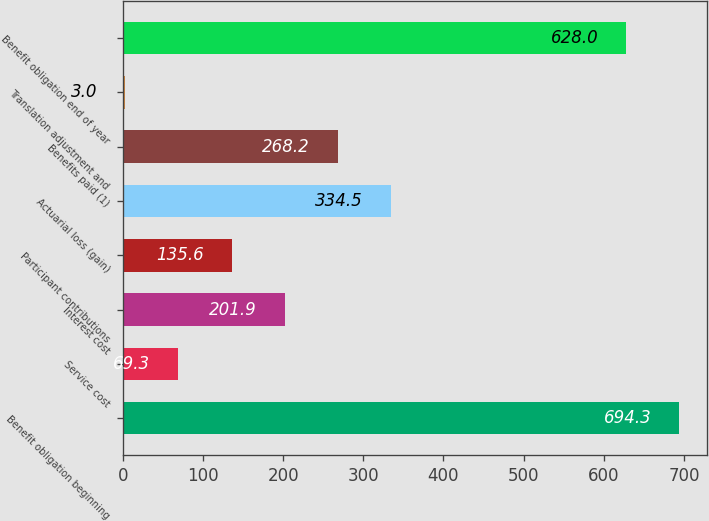Convert chart. <chart><loc_0><loc_0><loc_500><loc_500><bar_chart><fcel>Benefit obligation beginning<fcel>Service cost<fcel>Interest cost<fcel>Participant contributions<fcel>Actuarial loss (gain)<fcel>Benefits paid (1)<fcel>Translation adjustment and<fcel>Benefit obligation end of year<nl><fcel>694.3<fcel>69.3<fcel>201.9<fcel>135.6<fcel>334.5<fcel>268.2<fcel>3<fcel>628<nl></chart> 